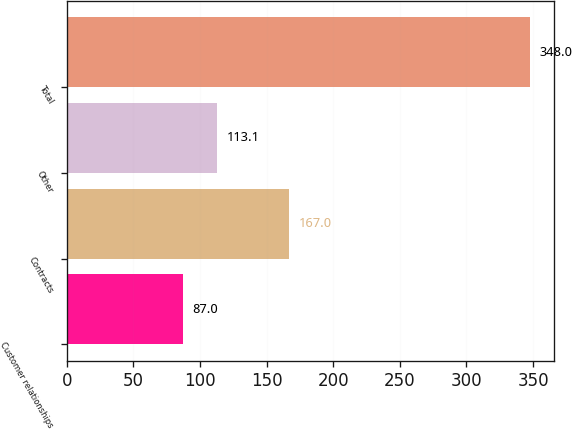Convert chart to OTSL. <chart><loc_0><loc_0><loc_500><loc_500><bar_chart><fcel>Customer relationships<fcel>Contracts<fcel>Other<fcel>Total<nl><fcel>87<fcel>167<fcel>113.1<fcel>348<nl></chart> 